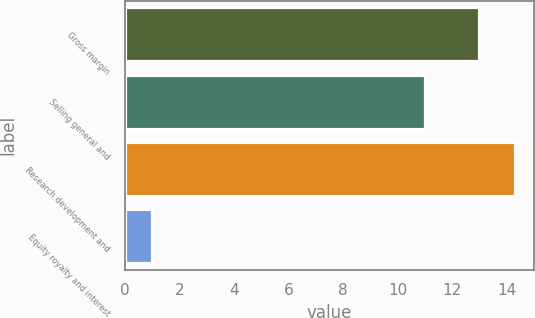<chart> <loc_0><loc_0><loc_500><loc_500><bar_chart><fcel>Gross margin<fcel>Selling general and<fcel>Research development and<fcel>Equity royalty and interest<nl><fcel>13<fcel>11<fcel>14.3<fcel>1<nl></chart> 